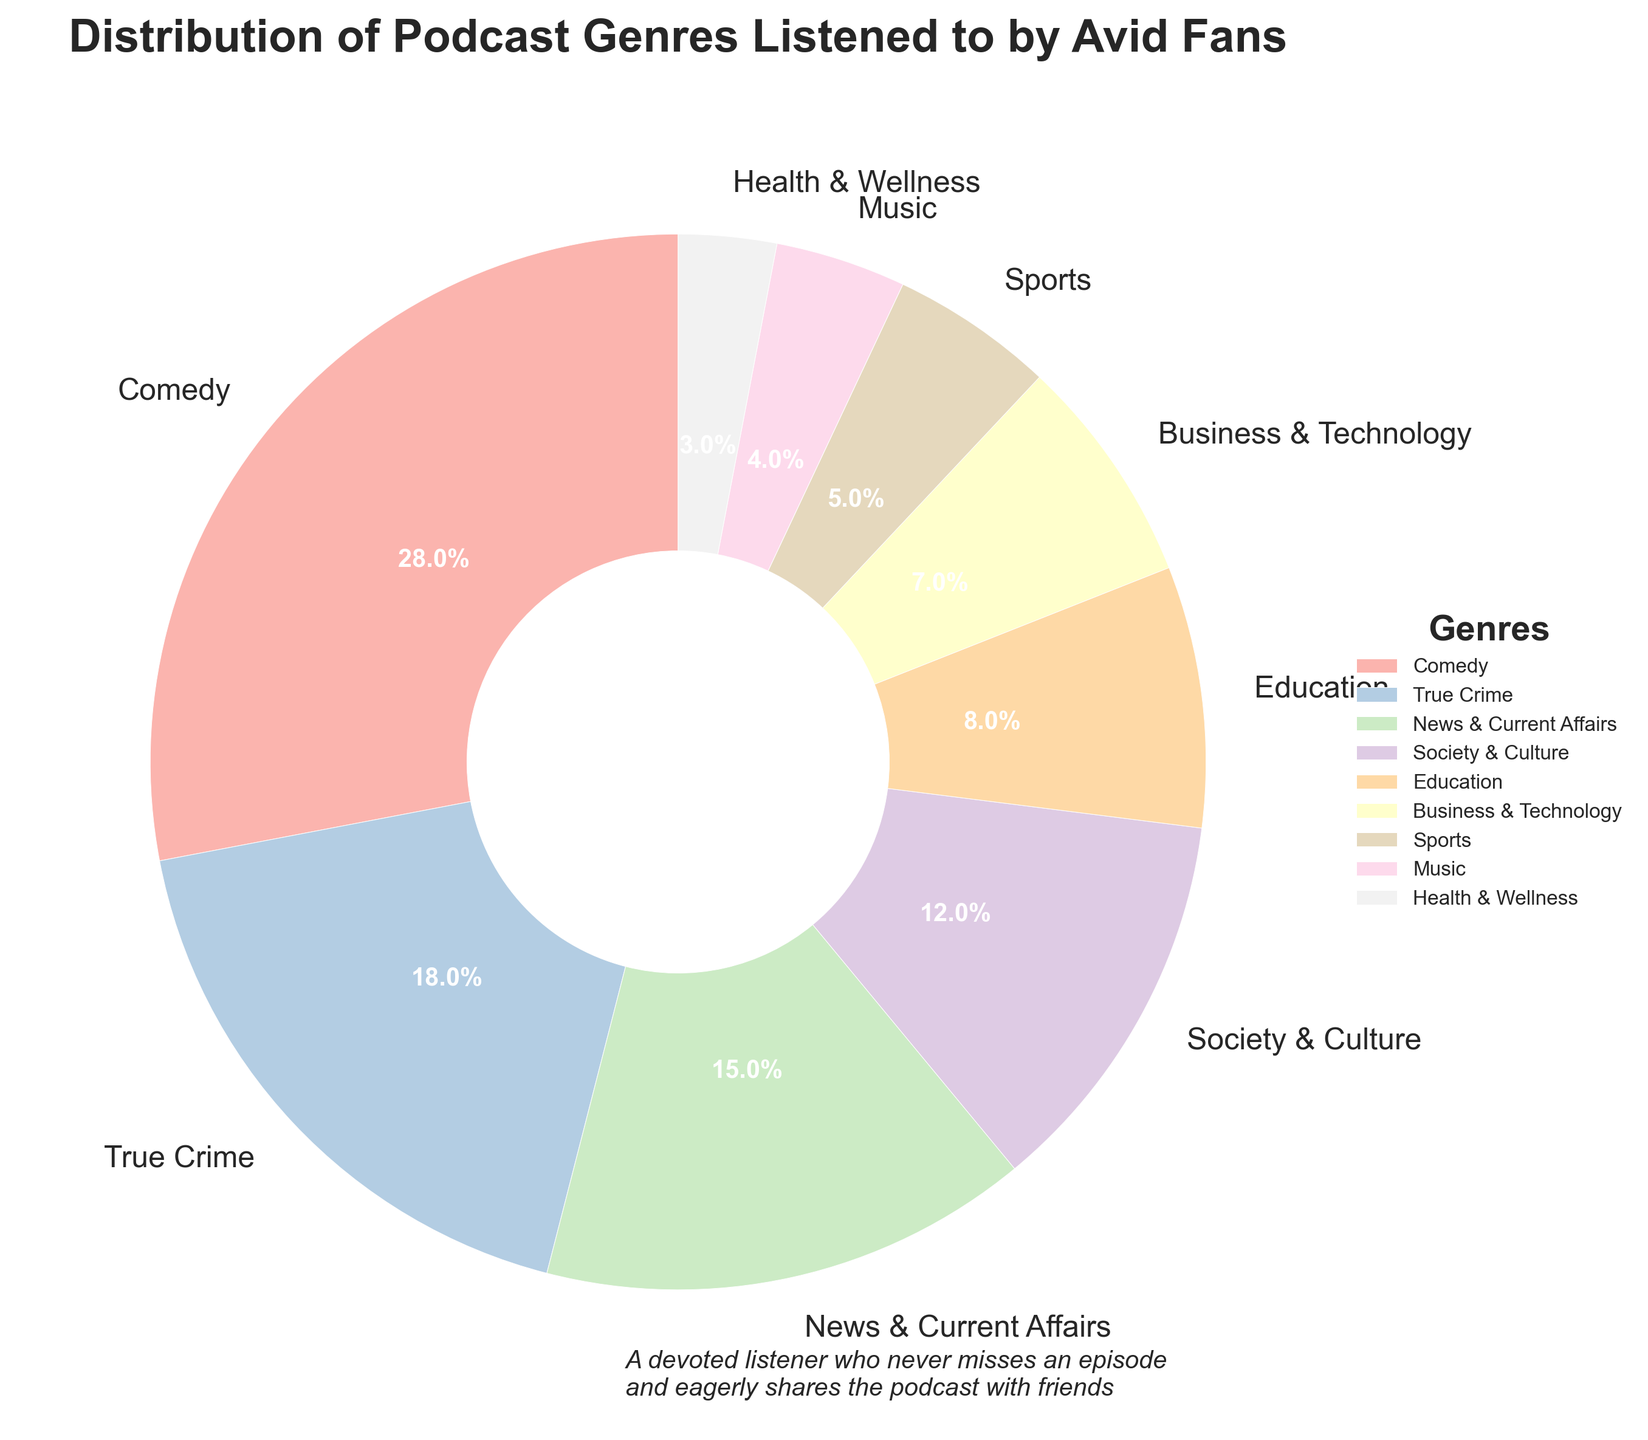What's the percentage of avid podcast fans who listen to Comedy and True Crime combined? To find the combined percentage of avid podcast fans who listen to Comedy and True Crime, sum the percentages for Comedy (28%) and True Crime (18%). The combined percentage is 28% + 18% = 46%.
Answer: 46% Which genre has the smallest percentage of listeners? To identify the genre with the smallest percentage, observe the percentages for each genre. Health & Wellness has the smallest percentage at 3%.
Answer: Health & Wellness Which has a higher percentage of listeners, Business & Technology or Education? Compare the percentages of Business & Technology (7%) and Education (8%). Education has a higher percentage.
Answer: Education What is the difference in the percentage of listeners between News & Current Affairs and Music? Subtract the percentage of Music listeners (4%) from the percentage of News & Current Affairs listeners (15%). The difference is 15% - 4% = 11%.
Answer: 11% What is the most listened to genre, and what is its percentage? Identify the genre with the highest percentage of listeners. Comedy has the highest percentage at 28%.
Answer: Comedy, 28% What is the sum of the percentages of the three least popular genres? Add the percentages of the three least popular genres: Health & Wellness (3%), Music (4%), and Sports (5%). The sum is 3% + 4% + 5% = 12%.
Answer: 12% Which genre's wedge is visually the largest on the pie chart? Determine which genre's wedge covers the largest area on the pie chart. Comedy's wedge is visually the largest, as it represents the highest percentage (28%).
Answer: Comedy Are there more fans of Society & Culture or Business & Technology combined than Comedy? Sum the percentages for Society & Culture (12%) and Business & Technology (7%), then compare it to Comedy (28%). The combined percentage is 12% + 7% = 19%, which is less than Comedy's 28%.
Answer: No Which genre has slightly over half the percentage of True Crime listeners? Determine half of True Crime's percentage: 18% ÷ 2 = 9%. Look for a genre close to this value. Business & Technology, at 7%, is slightly over half of 9%.
Answer: Business & Technology 